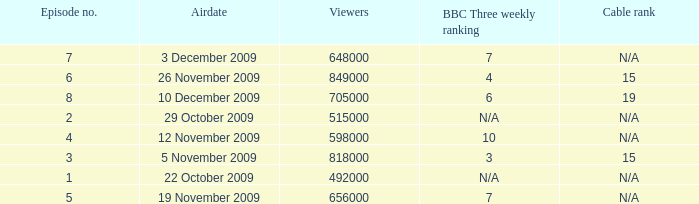What is the cable rank for bbc three weekly ranking of n/a? N/A, N/A. 